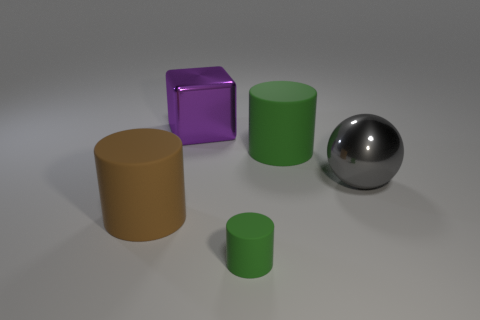Subtract 1 cylinders. How many cylinders are left? 2 Subtract all large cylinders. How many cylinders are left? 1 Add 1 purple cubes. How many objects exist? 6 Subtract all cubes. How many objects are left? 4 Add 1 gray objects. How many gray objects exist? 2 Subtract 0 purple cylinders. How many objects are left? 5 Subtract all brown things. Subtract all large gray metallic spheres. How many objects are left? 3 Add 3 big gray balls. How many big gray balls are left? 4 